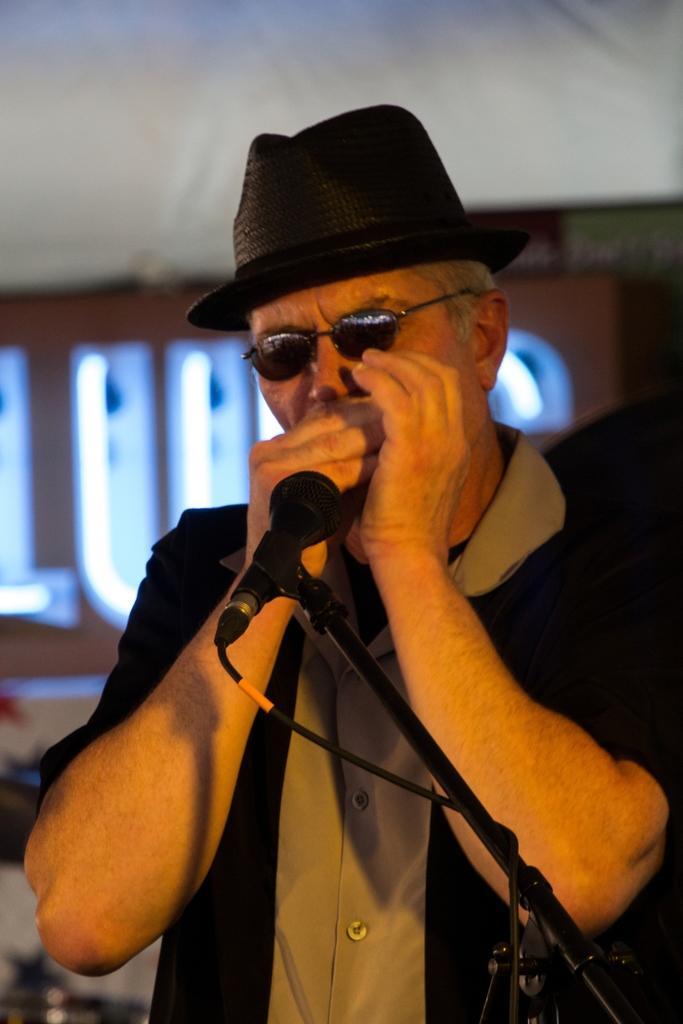In one or two sentences, can you explain what this image depicts? In this picture we can see a man with a hat and the man is doing something. In front of the man there is a microphone with the stand and a cable. Behind the man there is a name board and some blurred objects. 